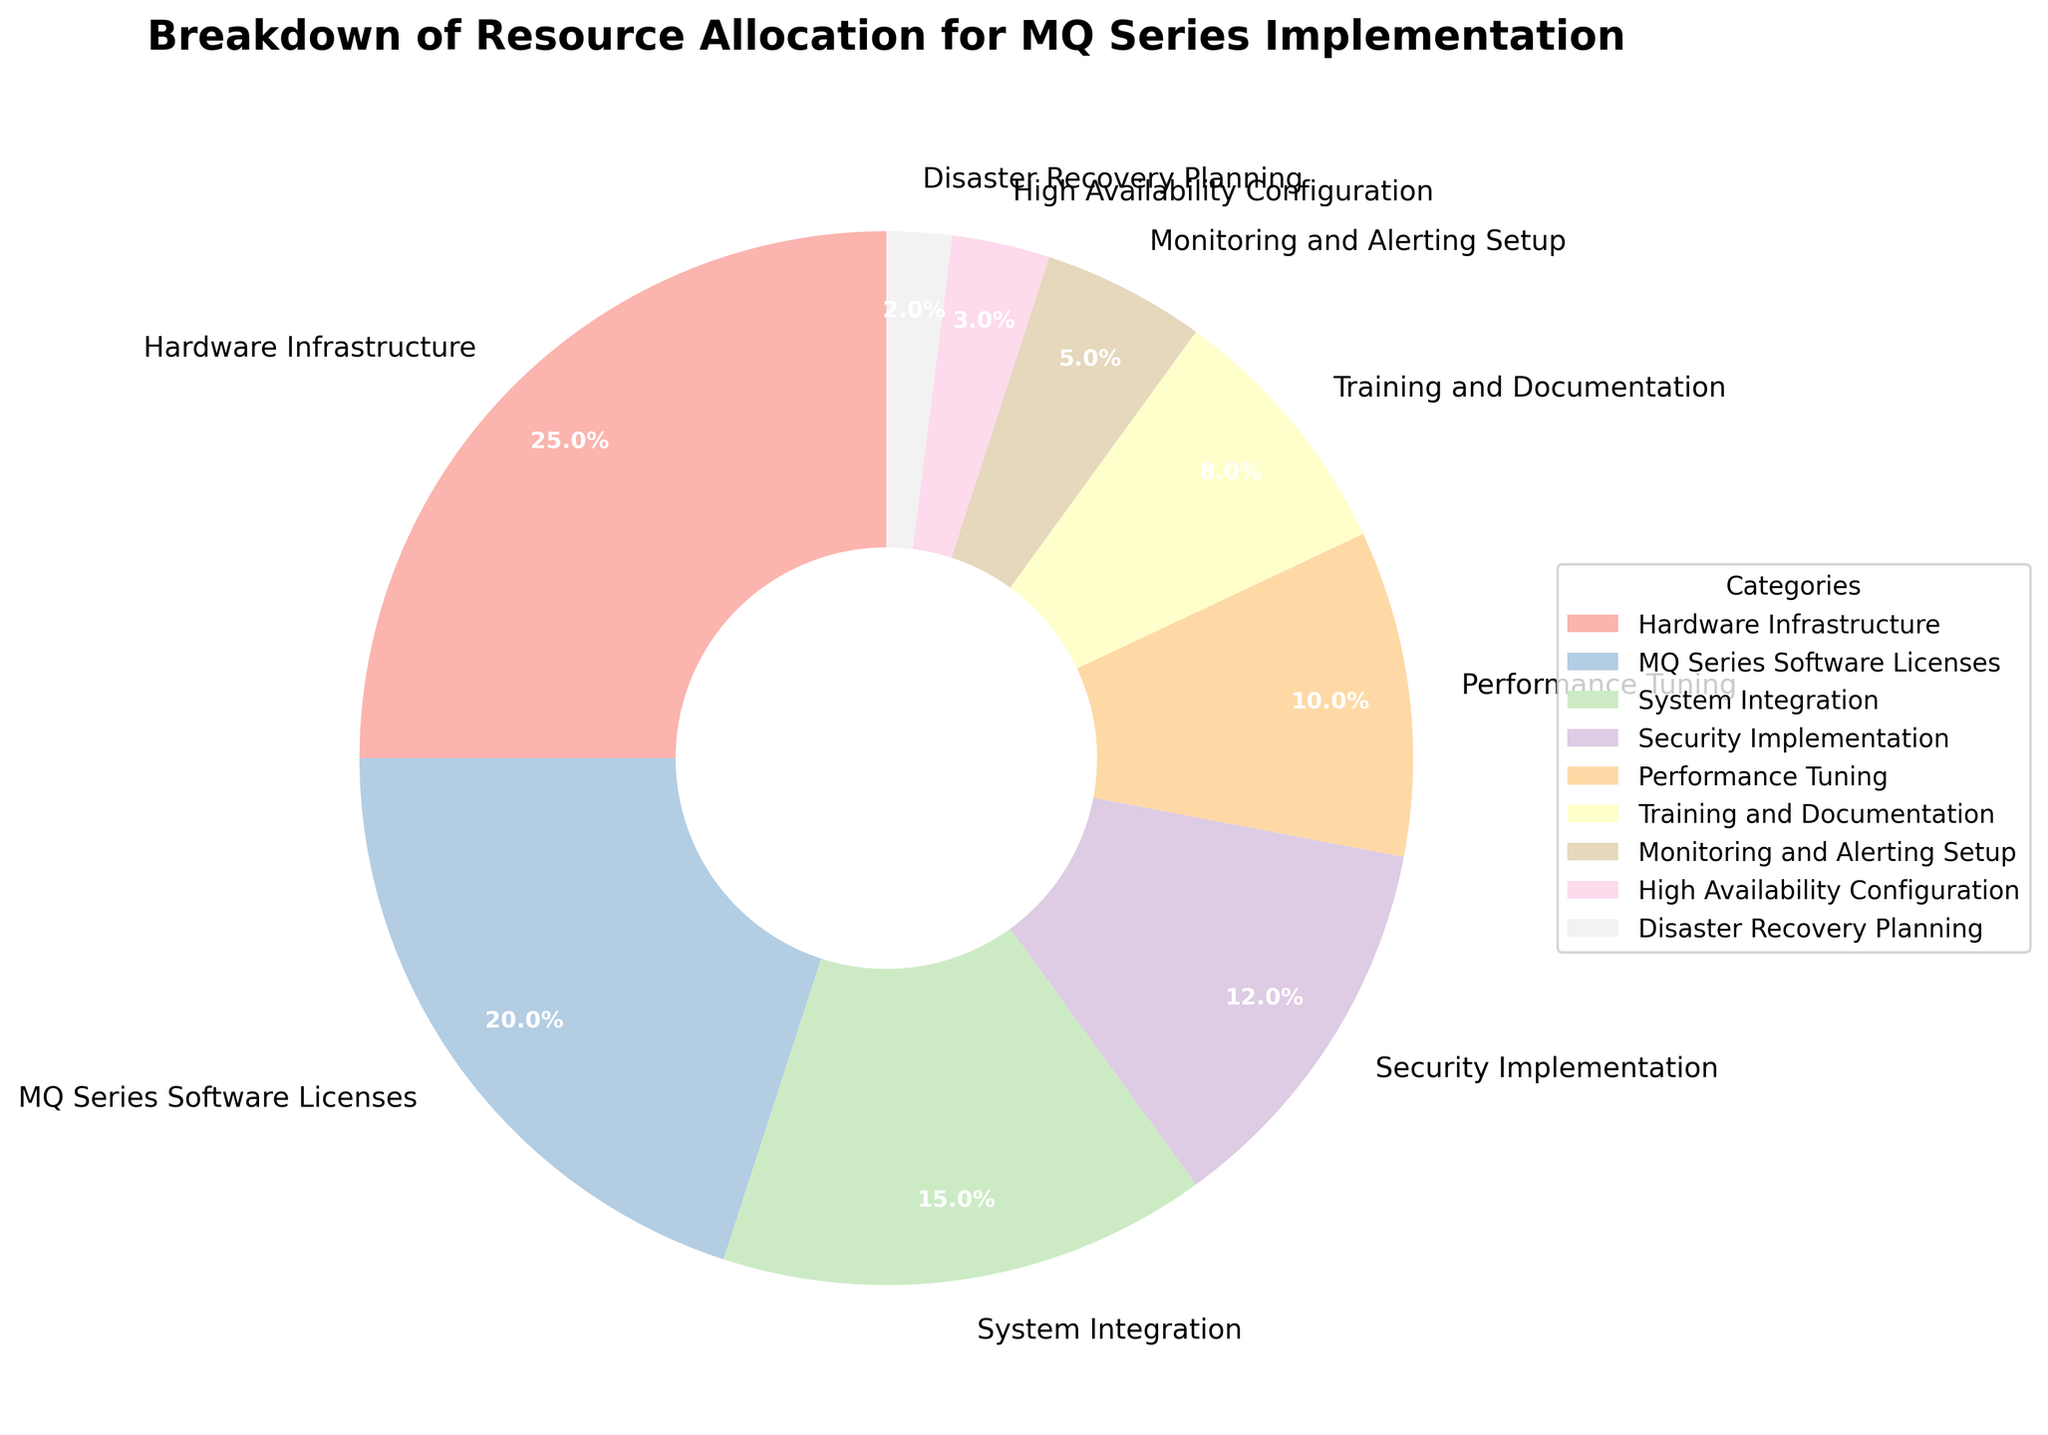What percentage of the resource allocation goes to Performance Tuning? According to the chart, Performance Tuning is represented as a section of the pie with 10% labeled on it.
Answer: 10% What is the total percentage of resources allocated to Hardware Infrastructure and Security Implementation combined? The chart shows 25% for Hardware Infrastructure and 12% for Security Implementation. Adding these together: 25% + 12% = 37%.
Answer: 37% Which category has the lowest percentage of resource allocation? The pie chart indicates that Disaster Recovery Planning has the smallest section labeled with 2%.
Answer: Disaster Recovery Planning Compare the resource allocation between MQ Series Software Licenses and System Integration. Which one receives more resources? The chart shows MQ Series Software Licenses at 20% and System Integration at 15%. Comparing these, 20% is greater than 15%.
Answer: MQ Series Software Licenses What's the total percentage allocated to High Availability Configuration and Disaster Recovery Planning? The chart displays High Availability Configuration at 3% and Disaster Recovery Planning at 2%. Adding these together: 3% + 2% = 5%.
Answer: 5% How much more percentage is allocated to Hardware Infrastructure compared to Training and Documentation? According to the chart, Hardware Infrastructure is 25% and Training and Documentation is 8%. The difference is: 25% - 8% = 17%.
Answer: 17% What color represents the Monitoring and Alerting Setup category? Referring to the chart, each segment has a distinct pastel color. The segment labeled Monitoring and Alerting Setup is represented by a unique color in the legend.
Answer: (Best represented color choice in visual) If you combine the percentages of System Integration, Security Implementation, and Performance Tuning, what would the sum be? The chart displays System Integration at 15%, Security Implementation at 12%, and Performance Tuning at 10%. Adding these together: 15% + 12% + 10% = 37%.
Answer: 37% Which category receives exactly half of the percentage allocated to Hardware Infrastructure? The chart shows Hardware Infrastructure at 25%. To find half, we calculate: 25% / 2 = 12.5%. There is no category with exactly 12.5%, but Security Implementation is the closest with 12%.
Answer: None (closest is Security Implementation with 12%) What's the percentage difference in resource allocation between Security Implementation and Monitoring and Alerting Setup? The chart shows Security Implementation at 12% and Monitoring and Alerting Setup at 5%. The difference is: 12% - 5% = 7%.
Answer: 7% 